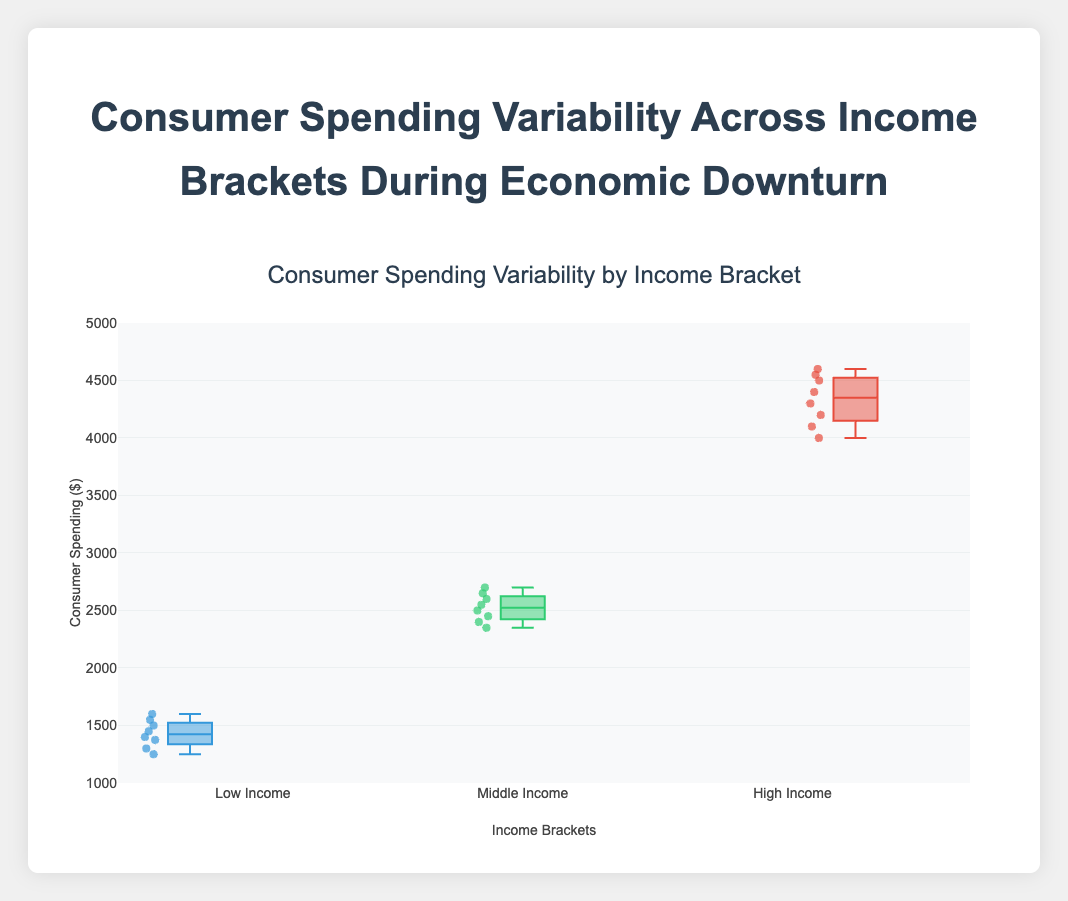How many income brackets are represented in the box plot? The box plot displays the consumer spending variability for three different income brackets. These can be seen as three different sets of box plots with distinct names.
Answer: Three What is the title of the box plot? The title of the box plot is displayed at the top of the figure, summarizing what the plot is about.
Answer: Consumer Spending Variability by Income Bracket Which income bracket has the highest median consumer spending? The median is the line inside each box. By comparing the boxes, the one with the highest median corresponds to the High Income bracket.
Answer: High Income Which income bracket shows the widest range of consumer spending? The range of consumer spending for each bracket can be determined by the distance from the minimum to the maximum data points (the spread of the whiskers). The High Income bracket has the widest range as the whiskers extend the farthest.
Answer: High Income What is the lower quartile (Q1) value for the Middle Income bracket? The lower quartile (Q1) is represented by the bottom edge of the box. For the Middle Income bracket, this value is around 2400.
Answer: ~2400 What is the interquartile range (IQR) for the Low Income bracket? The IQR is the distance between the upper quartile (Q3) and the lower quartile (Q1). Q3 for the Low Income bracket is around 1550, and Q1 is around 1375. The IQR is 1550 - 1375 = 175.
Answer: 175 Which income bracket has the smallest minimum consumer spending value? The minimum consumer spending value can be found at the lowest point of the whiskers for each box. The Low Income bracket has the smallest minimum value, which is around 1250.
Answer: Low Income How does the consumer spending variability of the Middle Income bracket compare to the High Income bracket? Consumer spending variability can be inferred from the width of the whiskers and the spread of the boxes. The High Income bracket has a greater variability, as it has a wider range of values.
Answer: Greater in High Income What conclusion can you draw about consumer spending habits during economic downturns for different income brackets? Analyzing the box plots, we see that High Income consumers have the highest spending and the most variability, Middle Income consumers have moderate spending and variability, while Low Income consumers have the lowest spending and least variability.
Answer: High Income: highest, most variability; Middle Income: moderate; Low Income: lowest, least variability 